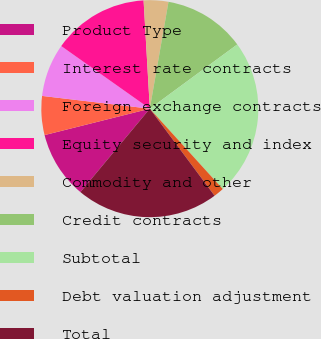Convert chart. <chart><loc_0><loc_0><loc_500><loc_500><pie_chart><fcel>Product Type<fcel>Interest rate contracts<fcel>Foreign exchange contracts<fcel>Equity security and index<fcel>Commodity and other<fcel>Credit contracts<fcel>Subtotal<fcel>Debt valuation adjustment<fcel>Total<nl><fcel>10.04%<fcel>5.79%<fcel>7.92%<fcel>14.29%<fcel>3.67%<fcel>12.16%<fcel>23.36%<fcel>1.55%<fcel>21.23%<nl></chart> 